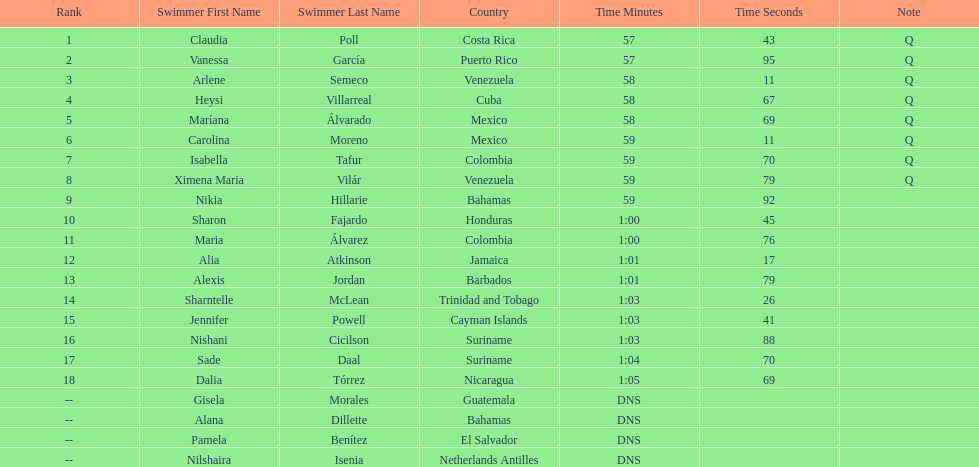Help me parse the entirety of this table. {'header': ['Rank', 'Swimmer First Name', 'Swimmer Last Name', 'Country', 'Time Minutes', 'Time Seconds', 'Note'], 'rows': [['1', 'Claudia', 'Poll', 'Costa Rica', '57', '43', 'Q'], ['2', 'Vanessa', 'García', 'Puerto Rico', '57', '95', 'Q'], ['3', 'Arlene', 'Semeco', 'Venezuela', '58', '11', 'Q'], ['4', 'Heysi', 'Villarreal', 'Cuba', '58', '67', 'Q'], ['5', 'Maríana', 'Álvarado', 'Mexico', '58', '69', 'Q'], ['6', 'Carolina', 'Moreno', 'Mexico', '59', '11', 'Q'], ['7', 'Isabella', 'Tafur', 'Colombia', '59', '70', 'Q'], ['8', 'Ximena Maria', 'Vilár', 'Venezuela', '59', '79', 'Q'], ['9', 'Nikia', 'Hillarie', 'Bahamas', '59', '92', ''], ['10', 'Sharon', 'Fajardo', 'Honduras', '1:00', '45', ''], ['11', 'Maria', 'Álvarez', 'Colombia', '1:00', '76', ''], ['12', 'Alia', 'Atkinson', 'Jamaica', '1:01', '17', ''], ['13', 'Alexis', 'Jordan', 'Barbados', '1:01', '79', ''], ['14', 'Sharntelle', 'McLean', 'Trinidad and Tobago', '1:03', '26', ''], ['15', 'Jennifer', 'Powell', 'Cayman Islands', '1:03', '41', ''], ['16', 'Nishani', 'Cicilson', 'Suriname', '1:03', '88', ''], ['17', 'Sade', 'Daal', 'Suriname', '1:04', '70', ''], ['18', 'Dalia', 'Tórrez', 'Nicaragua', '1:05', '69', ''], ['--', 'Gisela', 'Morales', 'Guatemala', 'DNS', '', ''], ['--', 'Alana', 'Dillette', 'Bahamas', 'DNS', '', ''], ['--', 'Pamela', 'Benítez', 'El Salvador', 'DNS', '', ''], ['--', 'Nilshaira', 'Isenia', 'Netherlands Antilles', 'DNS', '', '']]} What swimmer had the top or first rank? Claudia Poll. 